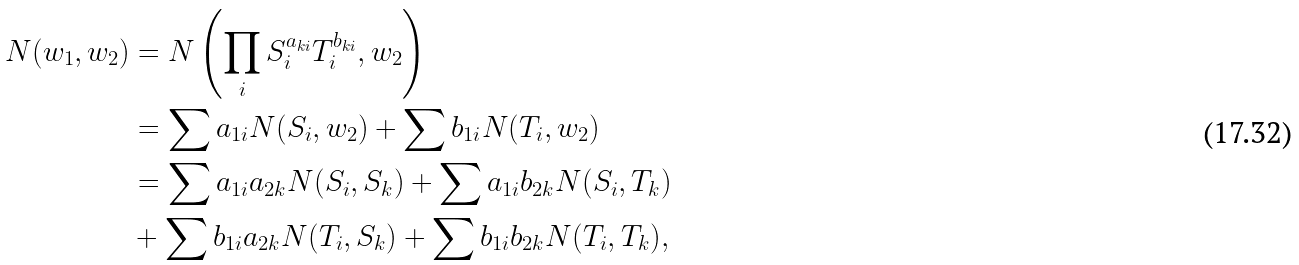<formula> <loc_0><loc_0><loc_500><loc_500>N ( w _ { 1 } , w _ { 2 } ) & = N \left ( \prod _ { i } S ^ { a _ { k i } } _ { i } T ^ { b _ { k i } } _ { i } , w _ { 2 } \right ) \\ & = \sum a _ { 1 i } N ( S _ { i } , w _ { 2 } ) + \sum b _ { 1 i } N ( T _ { i } , w _ { 2 } ) \\ & = \sum a _ { 1 i } a _ { 2 k } N ( S _ { i } , S _ { k } ) + \sum a _ { 1 i } b _ { 2 k } N ( S _ { i } , T _ { k } ) \\ & + \sum b _ { 1 i } a _ { 2 k } N ( T _ { i } , S _ { k } ) + \sum b _ { 1 i } b _ { 2 k } N ( T _ { i } , T _ { k } ) ,</formula> 